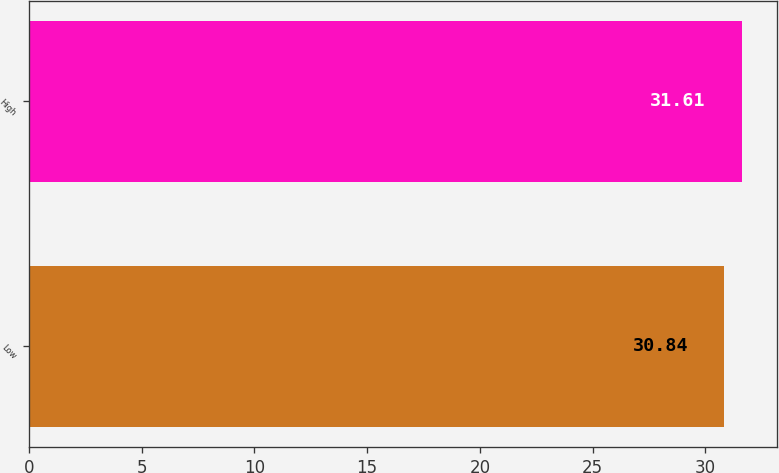<chart> <loc_0><loc_0><loc_500><loc_500><bar_chart><fcel>Low<fcel>High<nl><fcel>30.84<fcel>31.61<nl></chart> 